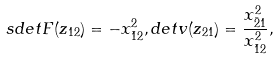<formula> <loc_0><loc_0><loc_500><loc_500>s d e t F ( z _ { 1 2 } ) = - x _ { \bar { 1 } 2 } ^ { 2 } , d e t v ( z _ { 2 1 } ) = \frac { x _ { \bar { 2 } 1 } ^ { 2 } } { x _ { \bar { 1 } 2 } ^ { 2 } } ,</formula> 